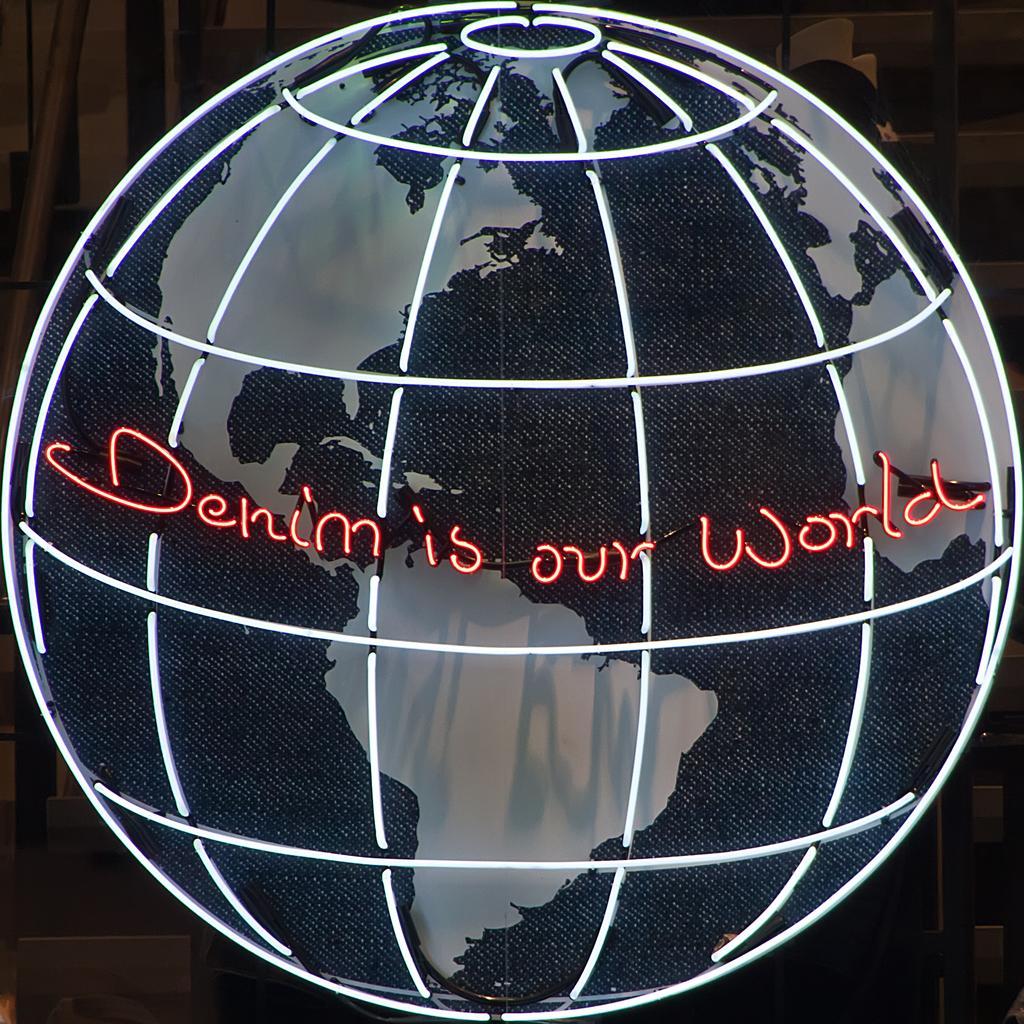Can you describe this image briefly? In this image I can see the LED sphere and I can see something is written on it and I can see the dark background. 